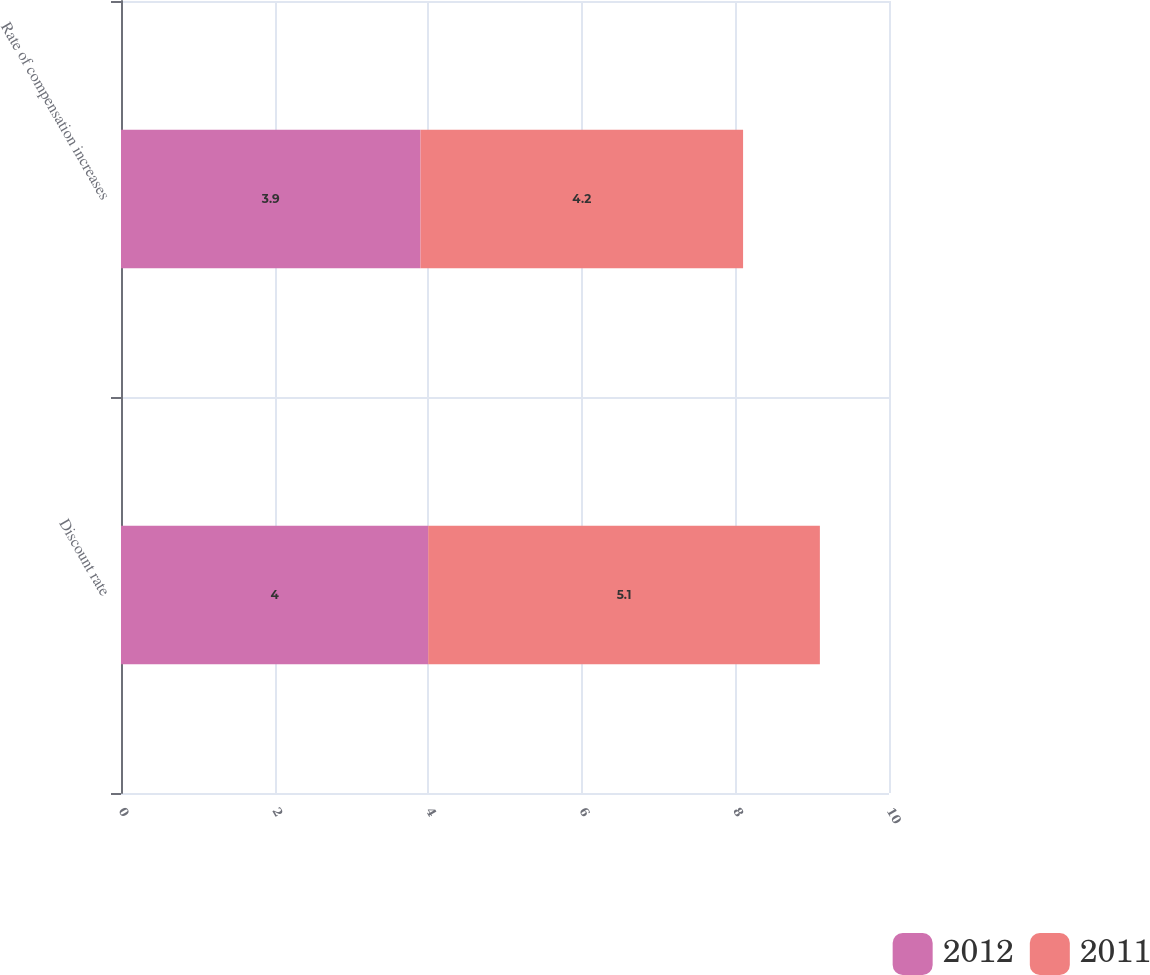Convert chart to OTSL. <chart><loc_0><loc_0><loc_500><loc_500><stacked_bar_chart><ecel><fcel>Discount rate<fcel>Rate of compensation increases<nl><fcel>2012<fcel>4<fcel>3.9<nl><fcel>2011<fcel>5.1<fcel>4.2<nl></chart> 